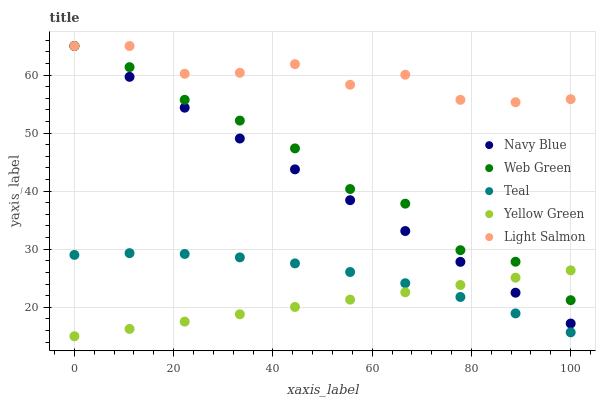Does Yellow Green have the minimum area under the curve?
Answer yes or no. Yes. Does Light Salmon have the maximum area under the curve?
Answer yes or no. Yes. Does Teal have the minimum area under the curve?
Answer yes or no. No. Does Teal have the maximum area under the curve?
Answer yes or no. No. Is Yellow Green the smoothest?
Answer yes or no. Yes. Is Light Salmon the roughest?
Answer yes or no. Yes. Is Teal the smoothest?
Answer yes or no. No. Is Teal the roughest?
Answer yes or no. No. Does Yellow Green have the lowest value?
Answer yes or no. Yes. Does Teal have the lowest value?
Answer yes or no. No. Does Web Green have the highest value?
Answer yes or no. Yes. Does Teal have the highest value?
Answer yes or no. No. Is Teal less than Navy Blue?
Answer yes or no. Yes. Is Web Green greater than Teal?
Answer yes or no. Yes. Does Teal intersect Yellow Green?
Answer yes or no. Yes. Is Teal less than Yellow Green?
Answer yes or no. No. Is Teal greater than Yellow Green?
Answer yes or no. No. Does Teal intersect Navy Blue?
Answer yes or no. No. 